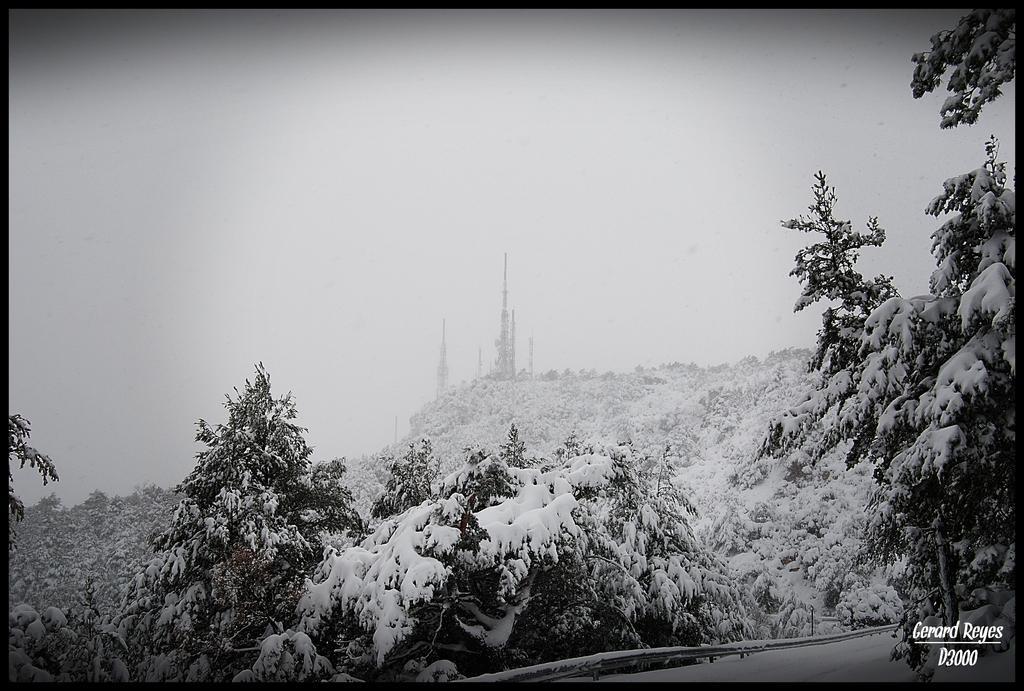Describe this image in one or two sentences. This image is a black and white image. This image is taken outdoors. At the bottom of the image there is a road. In the middle of the image there are many trees and plants covered with snow. At the top of the image there is a sky. 